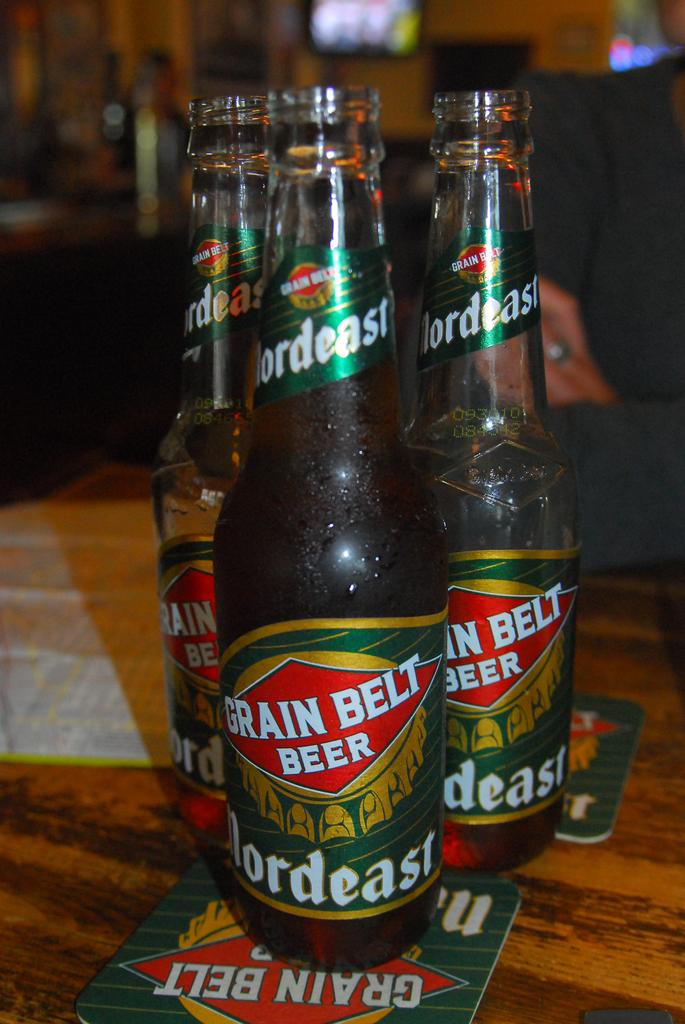Provide a one-sentence caption for the provided image. 3 bottles of grain belt beer next to each other. 